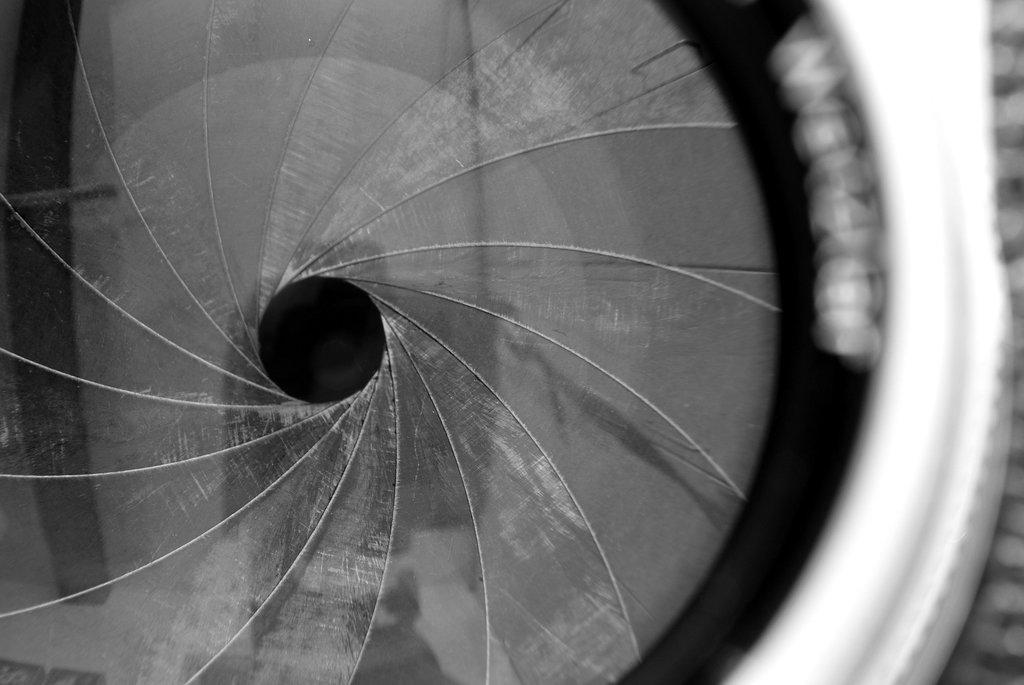What is the color scheme of the image? The image is black and white. What type of object can be seen in the image? There is a circular object in the image. What is the governor's opinion on the pest problem in the image? There is no governor or pest problem mentioned in the image; it only features a black and white circular object. 